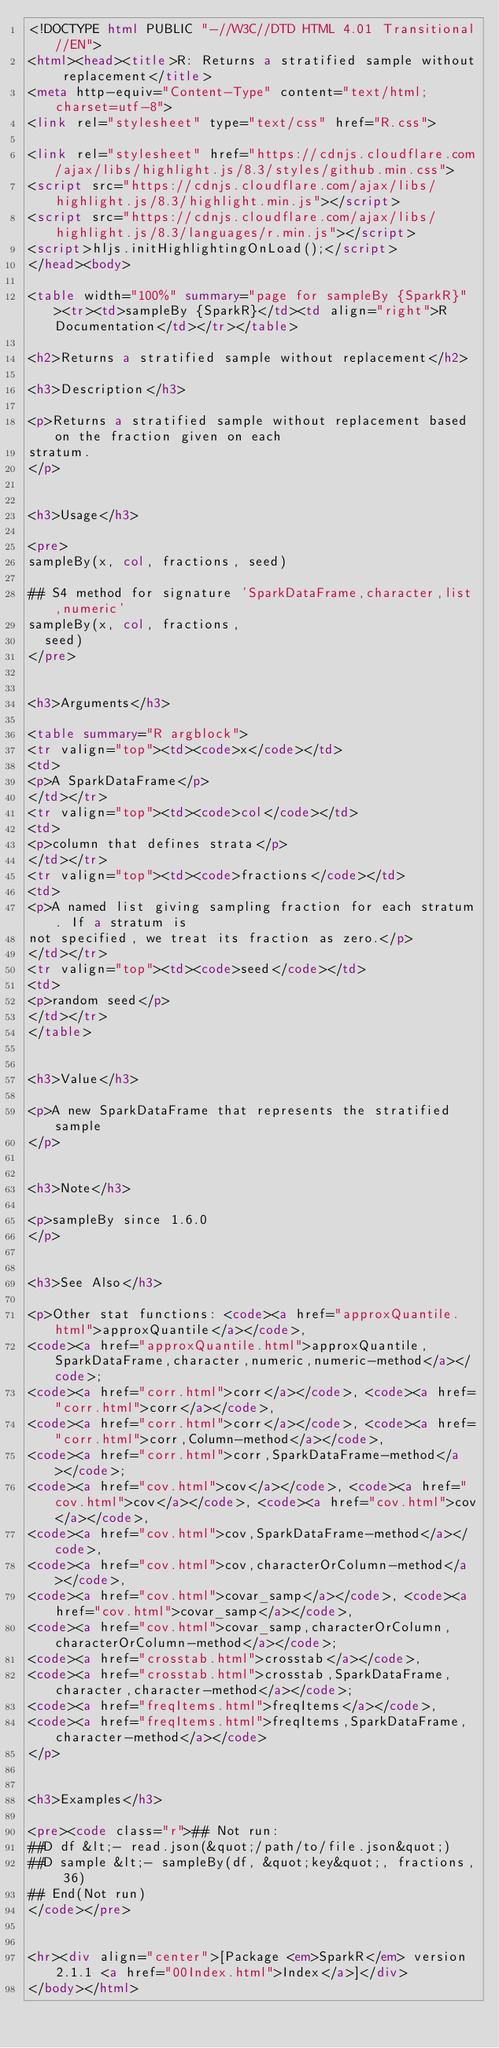Convert code to text. <code><loc_0><loc_0><loc_500><loc_500><_HTML_><!DOCTYPE html PUBLIC "-//W3C//DTD HTML 4.01 Transitional//EN">
<html><head><title>R: Returns a stratified sample without replacement</title>
<meta http-equiv="Content-Type" content="text/html; charset=utf-8">
<link rel="stylesheet" type="text/css" href="R.css">

<link rel="stylesheet" href="https://cdnjs.cloudflare.com/ajax/libs/highlight.js/8.3/styles/github.min.css">
<script src="https://cdnjs.cloudflare.com/ajax/libs/highlight.js/8.3/highlight.min.js"></script>
<script src="https://cdnjs.cloudflare.com/ajax/libs/highlight.js/8.3/languages/r.min.js"></script>
<script>hljs.initHighlightingOnLoad();</script>
</head><body>

<table width="100%" summary="page for sampleBy {SparkR}"><tr><td>sampleBy {SparkR}</td><td align="right">R Documentation</td></tr></table>

<h2>Returns a stratified sample without replacement</h2>

<h3>Description</h3>

<p>Returns a stratified sample without replacement based on the fraction given on each
stratum.
</p>


<h3>Usage</h3>

<pre>
sampleBy(x, col, fractions, seed)

## S4 method for signature 'SparkDataFrame,character,list,numeric'
sampleBy(x, col, fractions,
  seed)
</pre>


<h3>Arguments</h3>

<table summary="R argblock">
<tr valign="top"><td><code>x</code></td>
<td>
<p>A SparkDataFrame</p>
</td></tr>
<tr valign="top"><td><code>col</code></td>
<td>
<p>column that defines strata</p>
</td></tr>
<tr valign="top"><td><code>fractions</code></td>
<td>
<p>A named list giving sampling fraction for each stratum. If a stratum is
not specified, we treat its fraction as zero.</p>
</td></tr>
<tr valign="top"><td><code>seed</code></td>
<td>
<p>random seed</p>
</td></tr>
</table>


<h3>Value</h3>

<p>A new SparkDataFrame that represents the stratified sample
</p>


<h3>Note</h3>

<p>sampleBy since 1.6.0
</p>


<h3>See Also</h3>

<p>Other stat functions: <code><a href="approxQuantile.html">approxQuantile</a></code>,
<code><a href="approxQuantile.html">approxQuantile,SparkDataFrame,character,numeric,numeric-method</a></code>;
<code><a href="corr.html">corr</a></code>, <code><a href="corr.html">corr</a></code>,
<code><a href="corr.html">corr</a></code>, <code><a href="corr.html">corr,Column-method</a></code>,
<code><a href="corr.html">corr,SparkDataFrame-method</a></code>;
<code><a href="cov.html">cov</a></code>, <code><a href="cov.html">cov</a></code>, <code><a href="cov.html">cov</a></code>,
<code><a href="cov.html">cov,SparkDataFrame-method</a></code>,
<code><a href="cov.html">cov,characterOrColumn-method</a></code>,
<code><a href="cov.html">covar_samp</a></code>, <code><a href="cov.html">covar_samp</a></code>,
<code><a href="cov.html">covar_samp,characterOrColumn,characterOrColumn-method</a></code>;
<code><a href="crosstab.html">crosstab</a></code>,
<code><a href="crosstab.html">crosstab,SparkDataFrame,character,character-method</a></code>;
<code><a href="freqItems.html">freqItems</a></code>,
<code><a href="freqItems.html">freqItems,SparkDataFrame,character-method</a></code>
</p>


<h3>Examples</h3>

<pre><code class="r">## Not run: 
##D df &lt;- read.json(&quot;/path/to/file.json&quot;)
##D sample &lt;- sampleBy(df, &quot;key&quot;, fractions, 36)
## End(Not run)
</code></pre>


<hr><div align="center">[Package <em>SparkR</em> version 2.1.1 <a href="00Index.html">Index</a>]</div>
</body></html>
</code> 